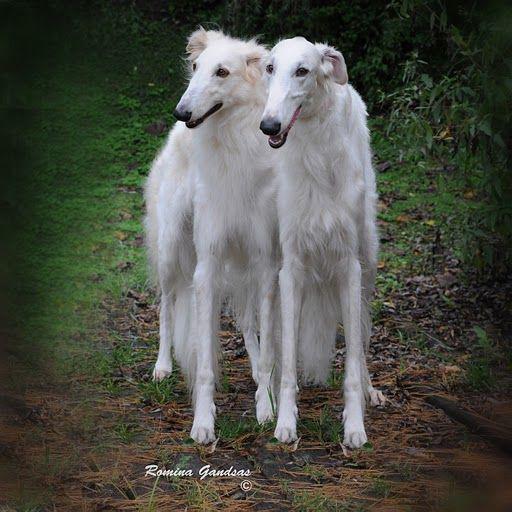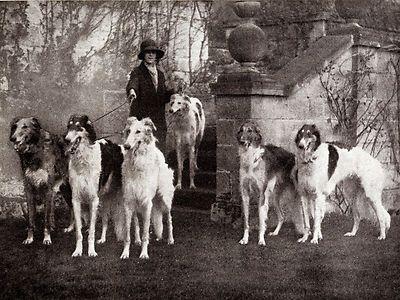The first image is the image on the left, the second image is the image on the right. Evaluate the accuracy of this statement regarding the images: "An image shows a lady in a dark gown standing behind one hound.". Is it true? Answer yes or no. No. The first image is the image on the left, the second image is the image on the right. Given the left and right images, does the statement "A woman is standing with a single dog." hold true? Answer yes or no. No. 